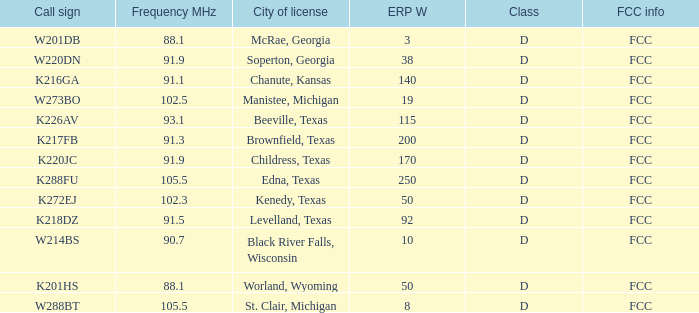What is City of License, when Frequency MHz is less than 102.5? McRae, Georgia, Soperton, Georgia, Chanute, Kansas, Beeville, Texas, Brownfield, Texas, Childress, Texas, Kenedy, Texas, Levelland, Texas, Black River Falls, Wisconsin, Worland, Wyoming. 